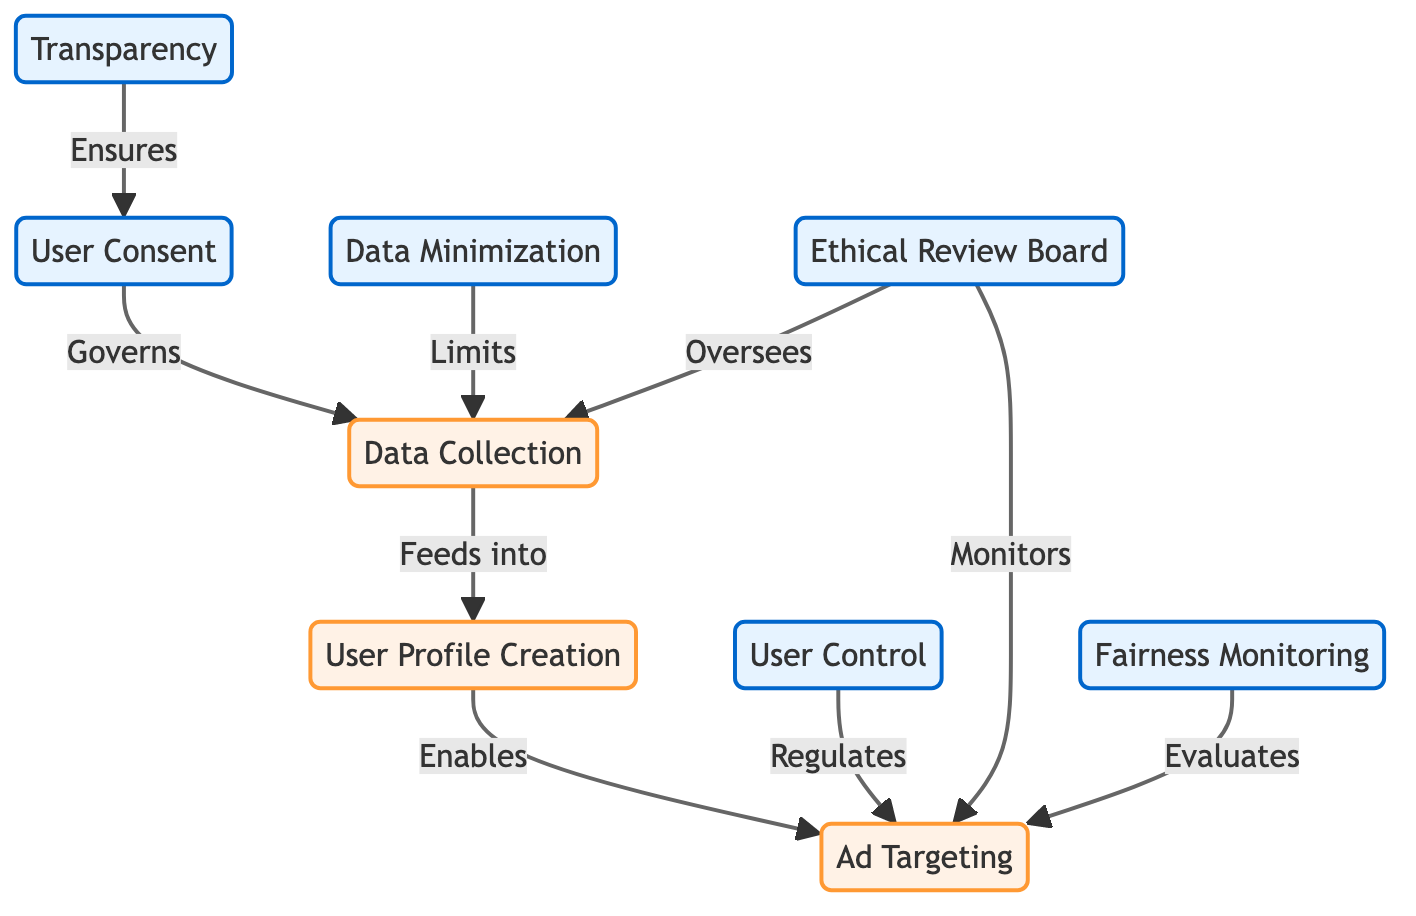What is the first node in the flowchart? The first node in the flowchart is "Data Collection," which is at the top of the diagram and serves as the starting point for the process.
Answer: Data Collection Which ethical consideration governs data collection? The ethical consideration that governs data collection is "User Consent," indicated by an arrow pointing from "User Consent" to "Data Collection" in the diagram.
Answer: User Consent How many ethical considerations are there in the diagram? There are five ethical considerations represented in the diagram: "User Consent," "Transparency," "Data Minimization," "User Control," and "Ethical Review Board."
Answer: Five What does "Data Minimization" limit? "Data Minimization" limits what is collected during "Data Collection," as shown by the arrow from "Data Minimization" pointing to "Data Collection."
Answer: Data Collection Which node ensures user consent? The node that ensures user consent is "Transparency," as it directly connects to "User Consent" in the diagram, indicating that transparency is crucial for obtaining consent.
Answer: Transparency What is the final output of the ad targeting process? The final output of the ad targeting process is influenced by the "User Control" ethical guideline that regulates how ads are targeted to users, ensuring that user privacy is respected.
Answer: User Control How is "Fairness Monitoring" related to "Ad Targeting"? "Fairness Monitoring" evaluates "Ad Targeting," as indicated by the arrow linking these two nodes, ensuring that targeted advertising practices are fair to all users.
Answer: Evaluates Which ethical consideration oversees both data collection and ad targeting? The ethical consideration that oversees both "Data Collection" and "Ad Targeting" is the "Ethical Review Board," which is shown by arrows connecting it to both process nodes.
Answer: Ethical Review Board What is the role of user control in the diagram? The role of "User Control" in the diagram is to regulate how ads are targeted, allowing users to have a say in the personalization of advertisements they receive.
Answer: Regulates 